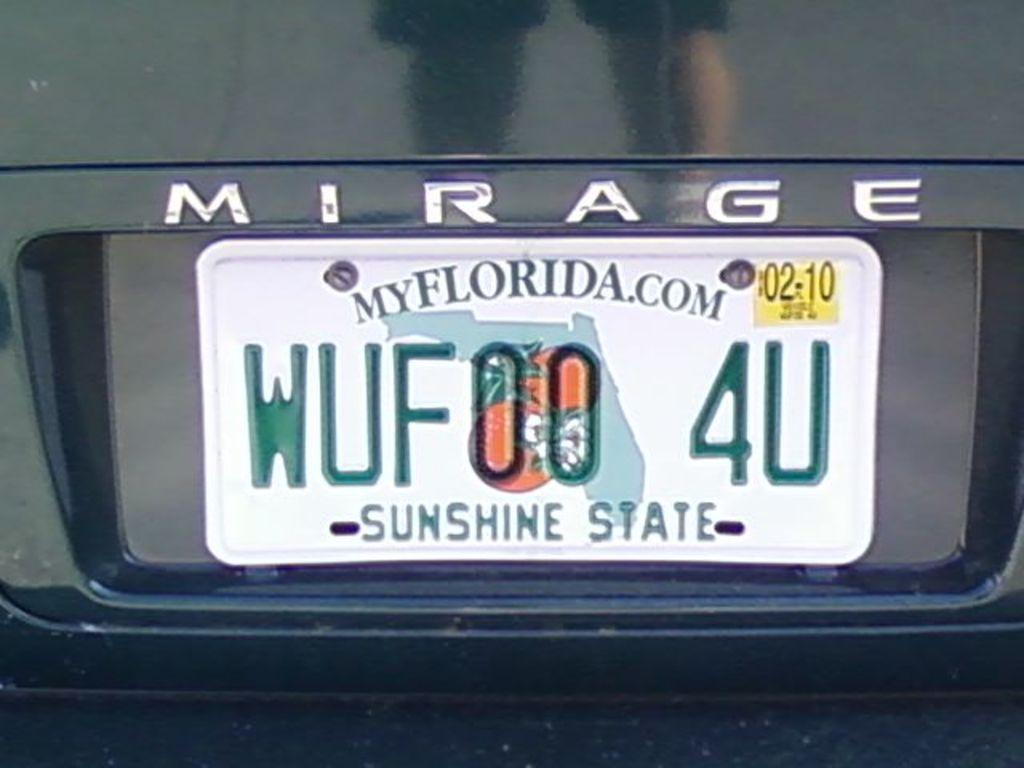<image>
Present a compact description of the photo's key features. A black car says Mirage above the license plate. 